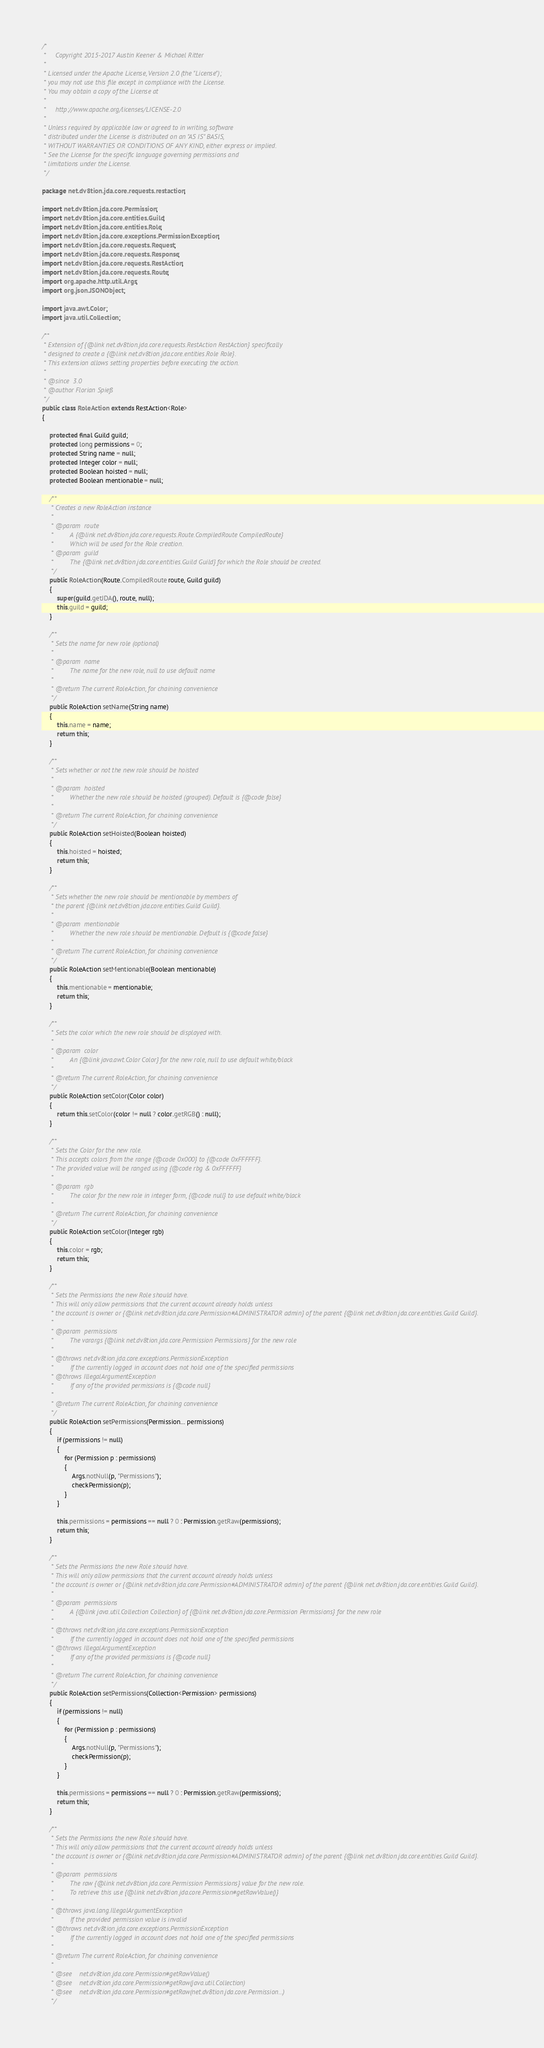<code> <loc_0><loc_0><loc_500><loc_500><_Java_>/*
 *     Copyright 2015-2017 Austin Keener & Michael Ritter
 *
 * Licensed under the Apache License, Version 2.0 (the "License");
 * you may not use this file except in compliance with the License.
 * You may obtain a copy of the License at
 *
 *     http://www.apache.org/licenses/LICENSE-2.0
 *
 * Unless required by applicable law or agreed to in writing, software
 * distributed under the License is distributed on an "AS IS" BASIS,
 * WITHOUT WARRANTIES OR CONDITIONS OF ANY KIND, either express or implied.
 * See the License for the specific language governing permissions and
 * limitations under the License.
 */

package net.dv8tion.jda.core.requests.restaction;

import net.dv8tion.jda.core.Permission;
import net.dv8tion.jda.core.entities.Guild;
import net.dv8tion.jda.core.entities.Role;
import net.dv8tion.jda.core.exceptions.PermissionException;
import net.dv8tion.jda.core.requests.Request;
import net.dv8tion.jda.core.requests.Response;
import net.dv8tion.jda.core.requests.RestAction;
import net.dv8tion.jda.core.requests.Route;
import org.apache.http.util.Args;
import org.json.JSONObject;

import java.awt.Color;
import java.util.Collection;

/**
 * Extension of {@link net.dv8tion.jda.core.requests.RestAction RestAction} specifically
 * designed to create a {@link net.dv8tion.jda.core.entities.Role Role}.
 * This extension allows setting properties before executing the action.
 *
 * @since  3.0
 * @author Florian Spieß
 */
public class RoleAction extends RestAction<Role>
{

    protected final Guild guild;
    protected long permissions = 0;
    protected String name = null;
    protected Integer color = null;
    protected Boolean hoisted = null;
    protected Boolean mentionable = null;

    /**
     * Creates a new RoleAction instance
     *
     * @param  route
     *         A {@link net.dv8tion.jda.core.requests.Route.CompiledRoute CompiledRoute}
     *         Which will be used for the Role creation.
     * @param  guild
     *         The {@link net.dv8tion.jda.core.entities.Guild Guild} for which the Role should be created.
     */
    public RoleAction(Route.CompiledRoute route, Guild guild)
    {
        super(guild.getJDA(), route, null);
        this.guild = guild;
    }

    /**
     * Sets the name for new role (optional)
     *
     * @param  name
     *         The name for the new role, null to use default name
     *
     * @return The current RoleAction, for chaining convenience
     */
    public RoleAction setName(String name)
    {
        this.name = name;
        return this;
    }

    /**
     * Sets whether or not the new role should be hoisted
     *
     * @param  hoisted
     *         Whether the new role should be hoisted (grouped). Default is {@code false}
     *
     * @return The current RoleAction, for chaining convenience
     */
    public RoleAction setHoisted(Boolean hoisted)
    {
        this.hoisted = hoisted;
        return this;
    }

    /**
     * Sets whether the new role should be mentionable by members of
     * the parent {@link net.dv8tion.jda.core.entities.Guild Guild}.
     *
     * @param  mentionable
     *         Whether the new role should be mentionable. Default is {@code false}
     *
     * @return The current RoleAction, for chaining convenience
     */
    public RoleAction setMentionable(Boolean mentionable)
    {
        this.mentionable = mentionable;
        return this;
    }

    /**
     * Sets the color which the new role should be displayed with.
     *
     * @param  color
     *         An {@link java.awt.Color Color} for the new role, null to use default white/black
     *
     * @return The current RoleAction, for chaining convenience
     */
    public RoleAction setColor(Color color)
    {
        return this.setColor(color != null ? color.getRGB() : null);
    }

    /**
     * Sets the Color for the new role.
     * This accepts colors from the range {@code 0x000} to {@code 0xFFFFFF}.
     * The provided value will be ranged using {@code rbg & 0xFFFFFF}
     *
     * @param  rgb
     *         The color for the new role in integer form, {@code null} to use default white/black
     *
     * @return The current RoleAction, for chaining convenience
     */
    public RoleAction setColor(Integer rgb)
    {
        this.color = rgb;
        return this;
    }

    /**
     * Sets the Permissions the new Role should have.
     * This will only allow permissions that the current account already holds unless
     * the account is owner or {@link net.dv8tion.jda.core.Permission#ADMINISTRATOR admin} of the parent {@link net.dv8tion.jda.core.entities.Guild Guild}.
     *
     * @param  permissions
     *         The varargs {@link net.dv8tion.jda.core.Permission Permissions} for the new role
     *
     * @throws net.dv8tion.jda.core.exceptions.PermissionException
     *         If the currently logged in account does not hold one of the specified permissions
     * @throws IllegalArgumentException
     *         If any of the provided permissions is {@code null}
     *
     * @return The current RoleAction, for chaining convenience
     */
    public RoleAction setPermissions(Permission... permissions)
    {
        if (permissions != null)
        {
            for (Permission p : permissions)
            {
                Args.notNull(p, "Permissions");
                checkPermission(p);
            }
        }

        this.permissions = permissions == null ? 0 : Permission.getRaw(permissions);
        return this;
    }

    /**
     * Sets the Permissions the new Role should have.
     * This will only allow permissions that the current account already holds unless
     * the account is owner or {@link net.dv8tion.jda.core.Permission#ADMINISTRATOR admin} of the parent {@link net.dv8tion.jda.core.entities.Guild Guild}.
     *
     * @param  permissions
     *         A {@link java.util.Collection Collection} of {@link net.dv8tion.jda.core.Permission Permissions} for the new role
     *
     * @throws net.dv8tion.jda.core.exceptions.PermissionException
     *         If the currently logged in account does not hold one of the specified permissions
     * @throws IllegalArgumentException
     *         If any of the provided permissions is {@code null}
     *
     * @return The current RoleAction, for chaining convenience
     */
    public RoleAction setPermissions(Collection<Permission> permissions)
    {
        if (permissions != null)
        {
            for (Permission p : permissions)
            {
                Args.notNull(p, "Permissions");
                checkPermission(p);
            }
        }

        this.permissions = permissions == null ? 0 : Permission.getRaw(permissions);
        return this;
    }

    /**
     * Sets the Permissions the new Role should have.
     * This will only allow permissions that the current account already holds unless
     * the account is owner or {@link net.dv8tion.jda.core.Permission#ADMINISTRATOR admin} of the parent {@link net.dv8tion.jda.core.entities.Guild Guild}.
     *
     * @param  permissions
     *         The raw {@link net.dv8tion.jda.core.Permission Permissions} value for the new role.
     *         To retrieve this use {@link net.dv8tion.jda.core.Permission#getRawValue()}
     *
     * @throws java.lang.IllegalArgumentException
     *         If the provided permission value is invalid
     * @throws net.dv8tion.jda.core.exceptions.PermissionException
     *         If the currently logged in account does not hold one of the specified permissions
     *
     * @return The current RoleAction, for chaining convenience
     *
     * @see    net.dv8tion.jda.core.Permission#getRawValue()
     * @see    net.dv8tion.jda.core.Permission#getRaw(java.util.Collection)
     * @see    net.dv8tion.jda.core.Permission#getRaw(net.dv8tion.jda.core.Permission...)
     */</code> 